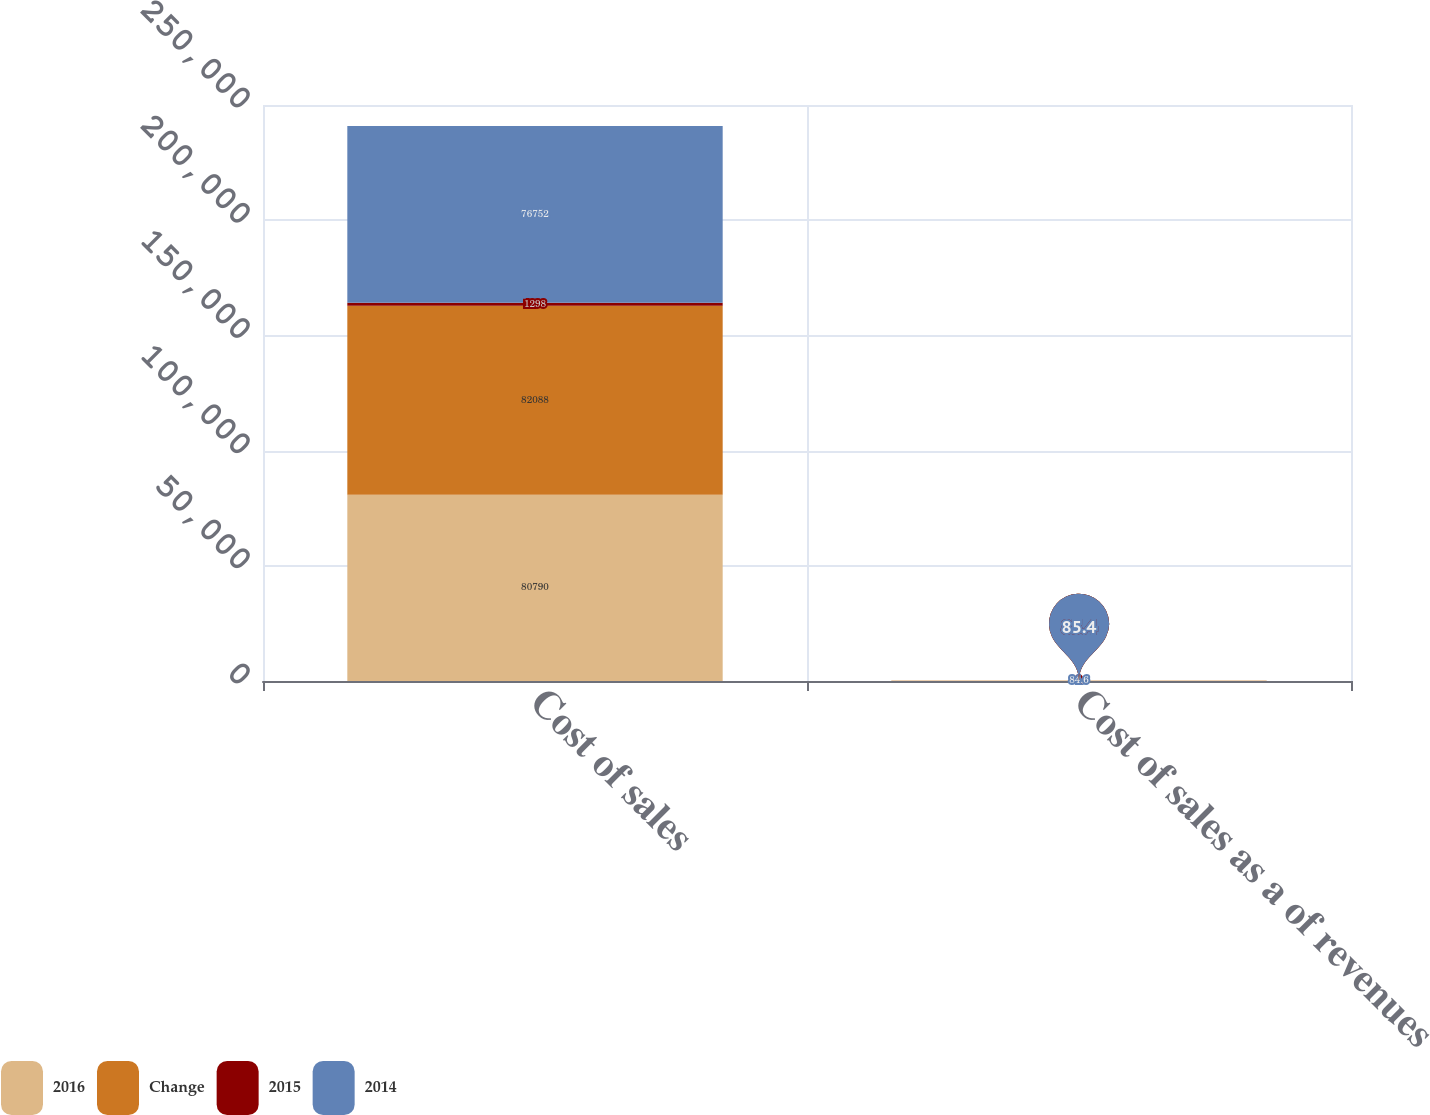<chart> <loc_0><loc_0><loc_500><loc_500><stacked_bar_chart><ecel><fcel>Cost of sales<fcel>Cost of sales as a of revenues<nl><fcel>2016<fcel>80790<fcel>85.4<nl><fcel>Change<fcel>82088<fcel>85.4<nl><fcel>2015<fcel>1298<fcel>0<nl><fcel>2014<fcel>76752<fcel>84.6<nl></chart> 